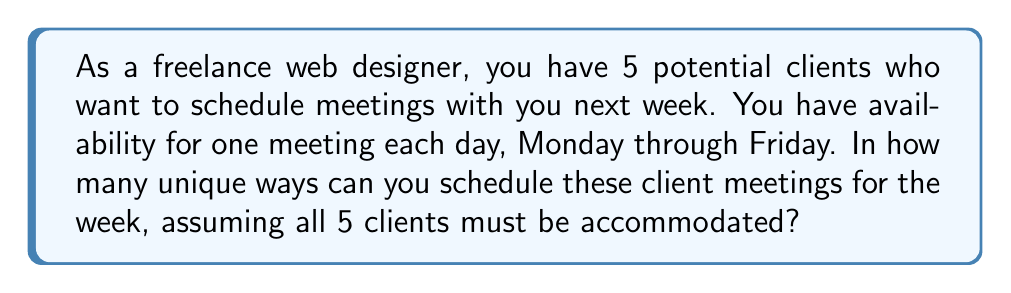Show me your answer to this math problem. Let's approach this step-by-step:

1) This is a permutation problem. We are arranging 5 clients into 5 available slots (one for each day of the work week).

2) The key here is to recognize that the order matters. For example, having Client A on Monday and Client B on Tuesday is different from having Client B on Monday and Client A on Tuesday.

3) When we have n distinct objects (in this case, 5 clients) and we want to arrange all of them, we use the permutation formula:

   $$P(n) = n!$$

4) In this case, n = 5, so we have:

   $$P(5) = 5!$$

5) Let's calculate this:
   
   $$5! = 5 \times 4 \times 3 \times 2 \times 1 = 120$$

6) Therefore, there are 120 unique ways to schedule the 5 client meetings over the 5 days of the work week.

This problem relates to your persona as a freelance web designer by focusing on scheduling client meetings, which is a common task in freelance work. The number of possible schedules (120) also illustrates the potential complexity of managing multiple clients, even in a single week.
Answer: 120 unique ways 